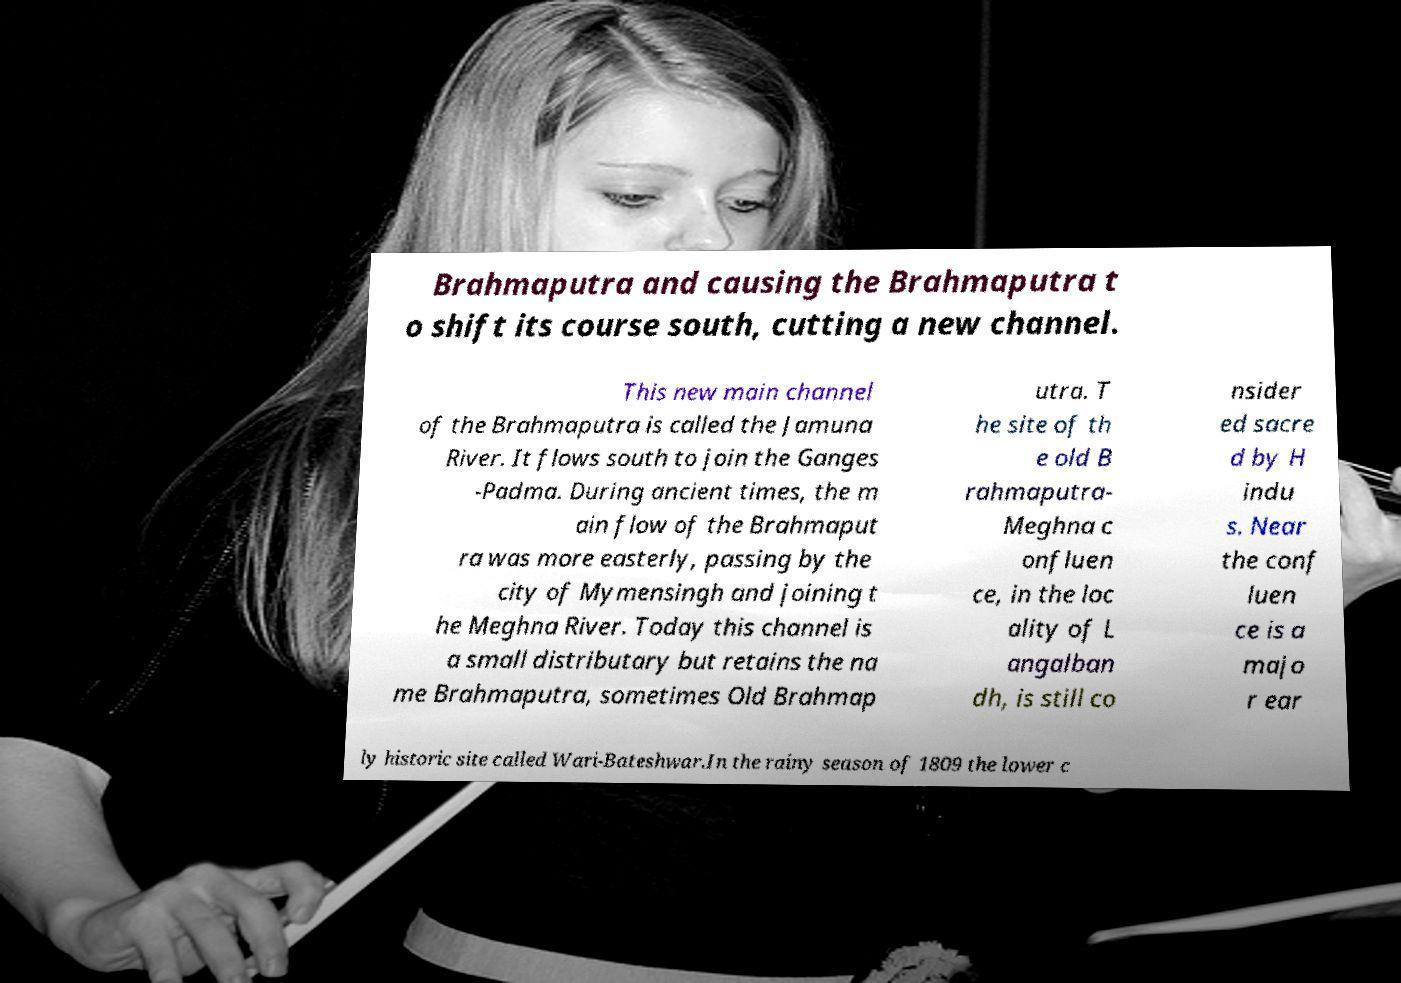Can you read and provide the text displayed in the image?This photo seems to have some interesting text. Can you extract and type it out for me? Brahmaputra and causing the Brahmaputra t o shift its course south, cutting a new channel. This new main channel of the Brahmaputra is called the Jamuna River. It flows south to join the Ganges -Padma. During ancient times, the m ain flow of the Brahmaput ra was more easterly, passing by the city of Mymensingh and joining t he Meghna River. Today this channel is a small distributary but retains the na me Brahmaputra, sometimes Old Brahmap utra. T he site of th e old B rahmaputra- Meghna c onfluen ce, in the loc ality of L angalban dh, is still co nsider ed sacre d by H indu s. Near the conf luen ce is a majo r ear ly historic site called Wari-Bateshwar.In the rainy season of 1809 the lower c 